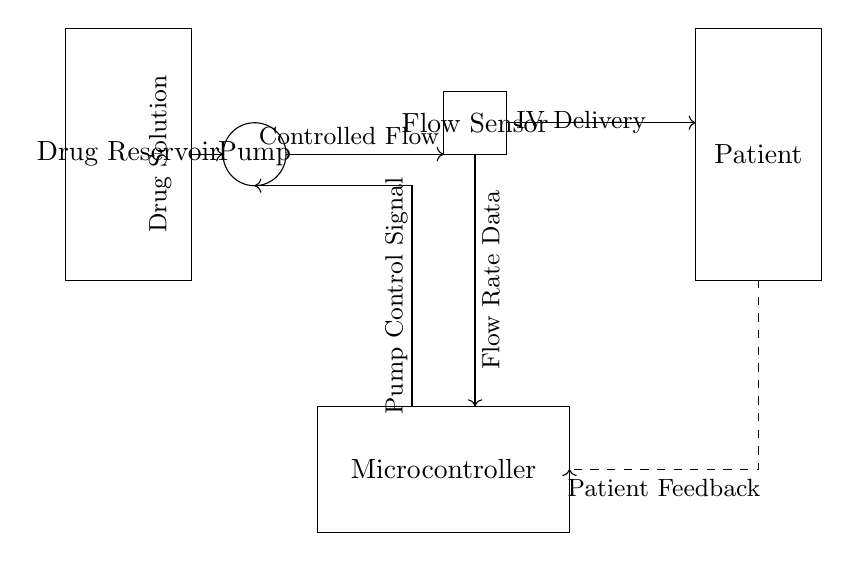What is the main component used for drug delivery? The main component for drug delivery in this circuit is the pump, which actively moves the drug solution from the reservoir to the patient.
Answer: Pump What does the flow sensor measure? The flow sensor is designed to measure the flow rate of the drug solution as it moves toward the patient, providing crucial data for dosage accuracy.
Answer: Flow rate Which component receives feedback from the patient? The component that receives feedback from the patient is the microcontroller, which interprets the data from the flow sensor and adjusts the pump's operation accordingly.
Answer: Microcontroller What is the function of the dashed feedback loop? The dashed feedback loop indicates the flow of data regarding the patient's response back to the microcontroller, allowing for real-time adjustments in drug delivery based on the patient's needs.
Answer: Patient Feedback How does the microcontroller interact with the pump? The microcontroller sends control signals to the pump based on the flow rate data it receives from the flow sensor, ensuring that the drug is administered precisely and appropriately.
Answer: Pump Control Signal What is the purpose of the drug reservoir? The drug reservoir serves as the storage unit for the intravenous drug solution, from which the pump draws to deliver to the patient.
Answer: Drug Reservoir 